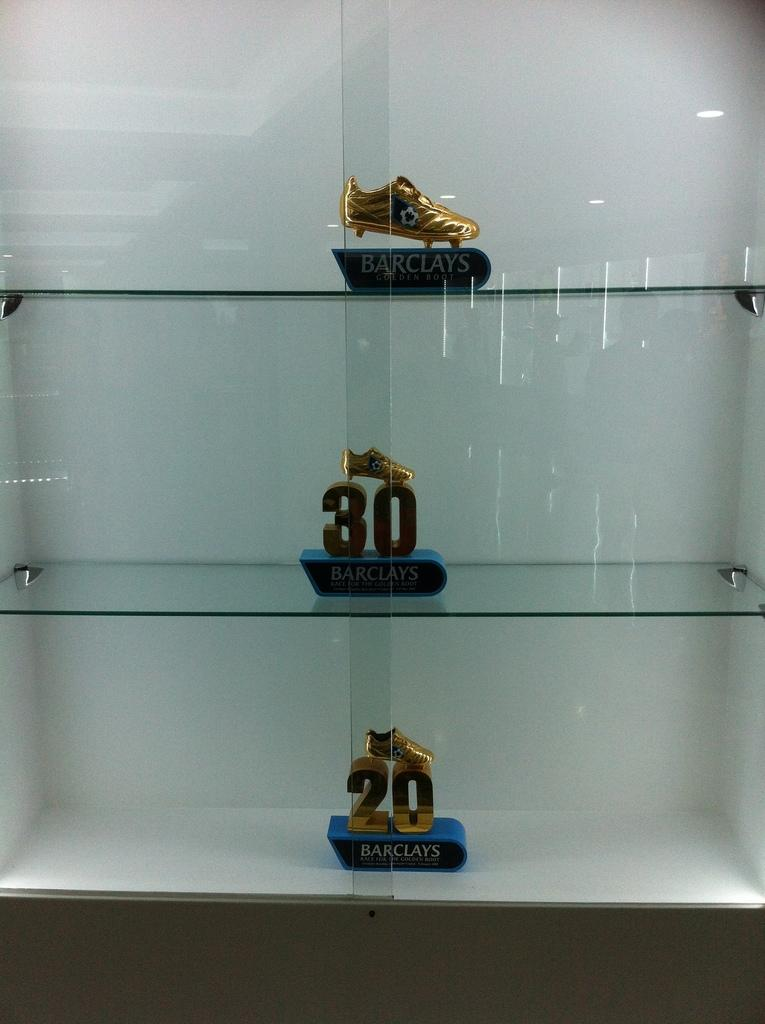What type of furniture is present in the image? There is a glass cupboard in the image. What is inside the cupboard? The cupboard contains three different items. Can you describe the items in the cupboard? The items have some text on them. What direction is the air blowing from in the image? There is no mention of air or any directional movement in the image. The focus is on the glass cupboard and its contents. 